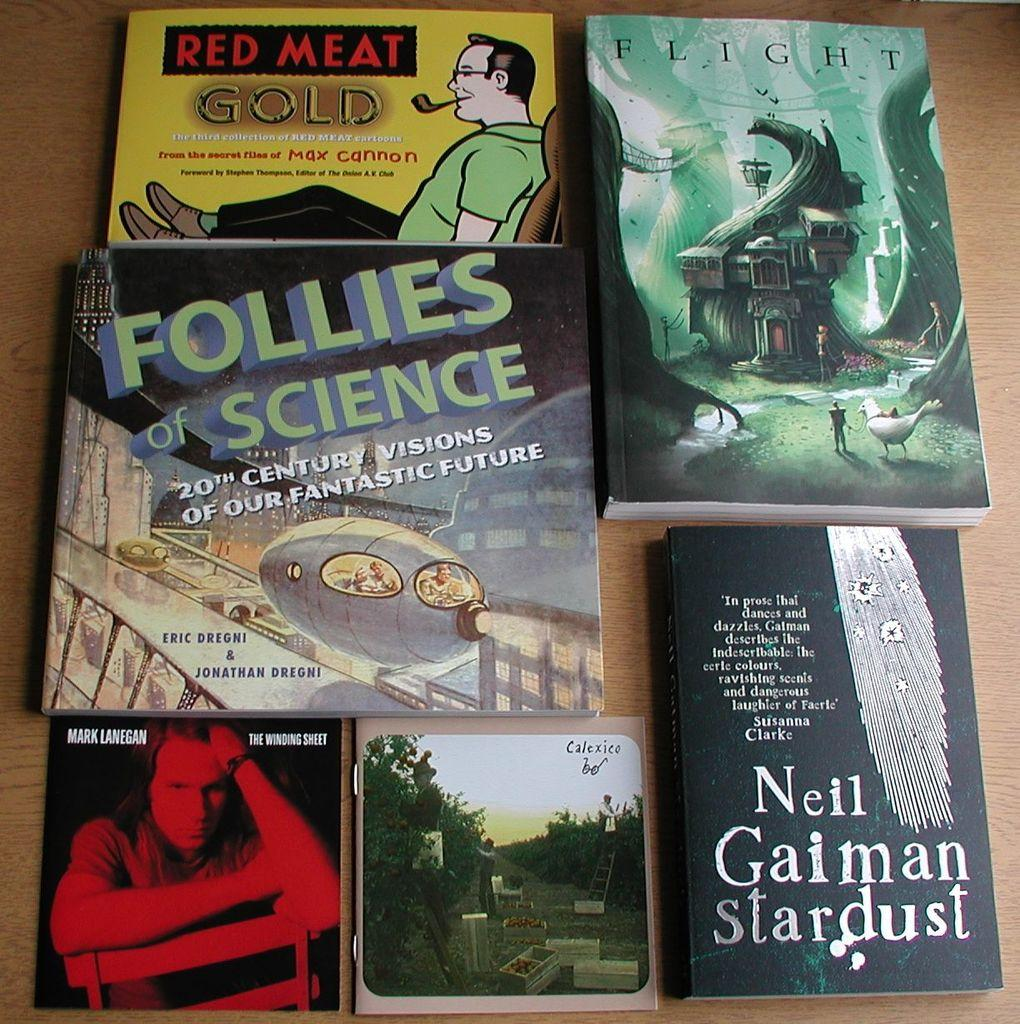Provide a one-sentence caption for the provided image. 6 books displayed on the table from different authors. 